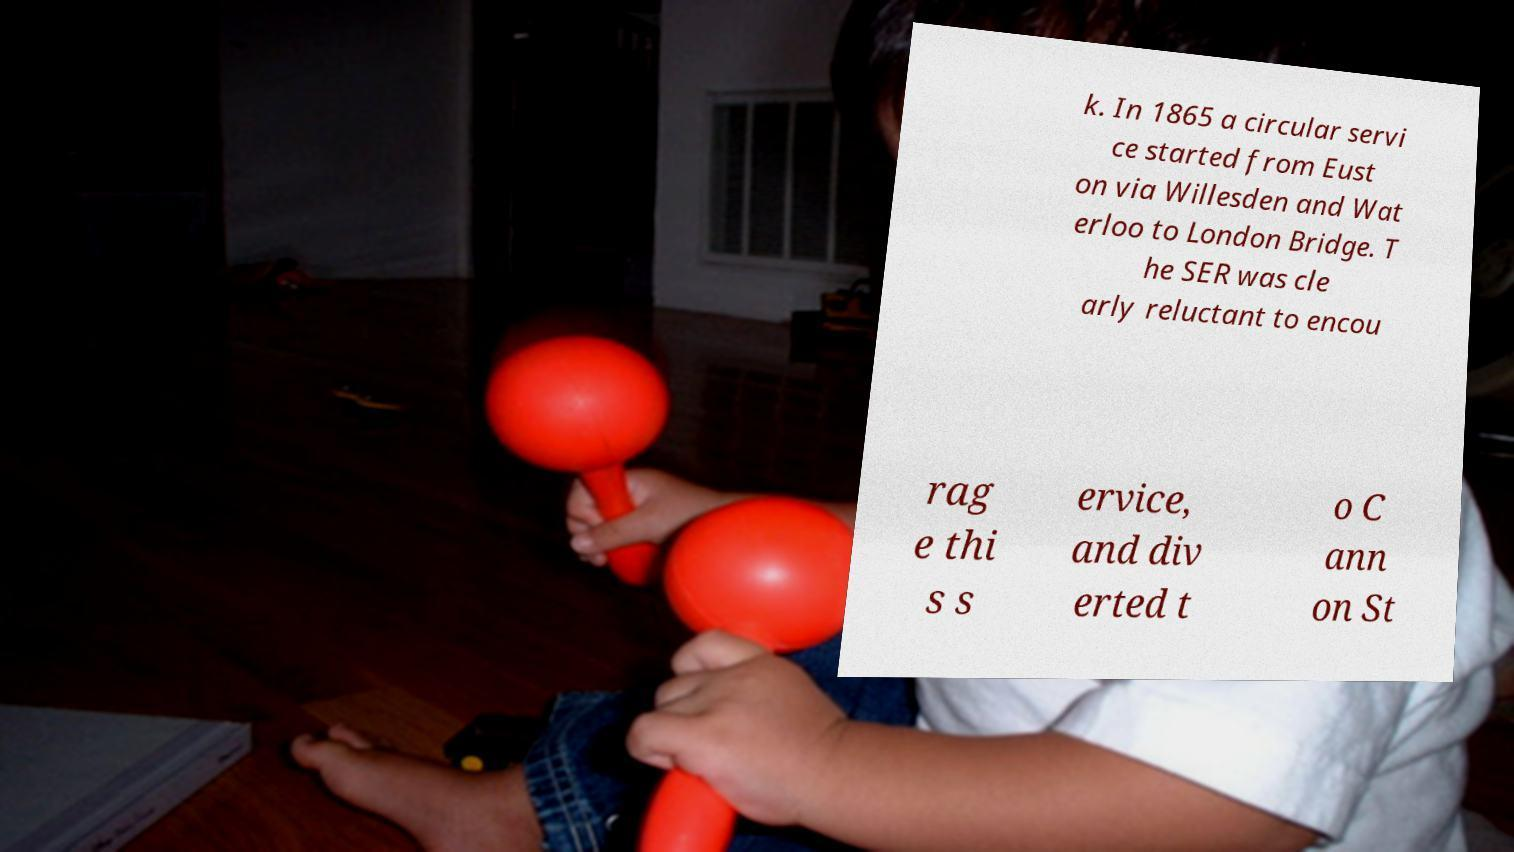Can you accurately transcribe the text from the provided image for me? k. In 1865 a circular servi ce started from Eust on via Willesden and Wat erloo to London Bridge. T he SER was cle arly reluctant to encou rag e thi s s ervice, and div erted t o C ann on St 